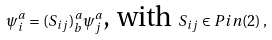<formula> <loc_0><loc_0><loc_500><loc_500>\psi _ { i } ^ { a } = ( S _ { i j } ) _ { b } ^ { a } \psi _ { j } ^ { a } \text {, with } S _ { i j } \in P i n ( 2 ) \, ,</formula> 